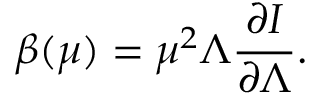Convert formula to latex. <formula><loc_0><loc_0><loc_500><loc_500>\beta ( \mu ) = \mu ^ { 2 } \Lambda \frac { \partial I } { \partial \Lambda } .</formula> 